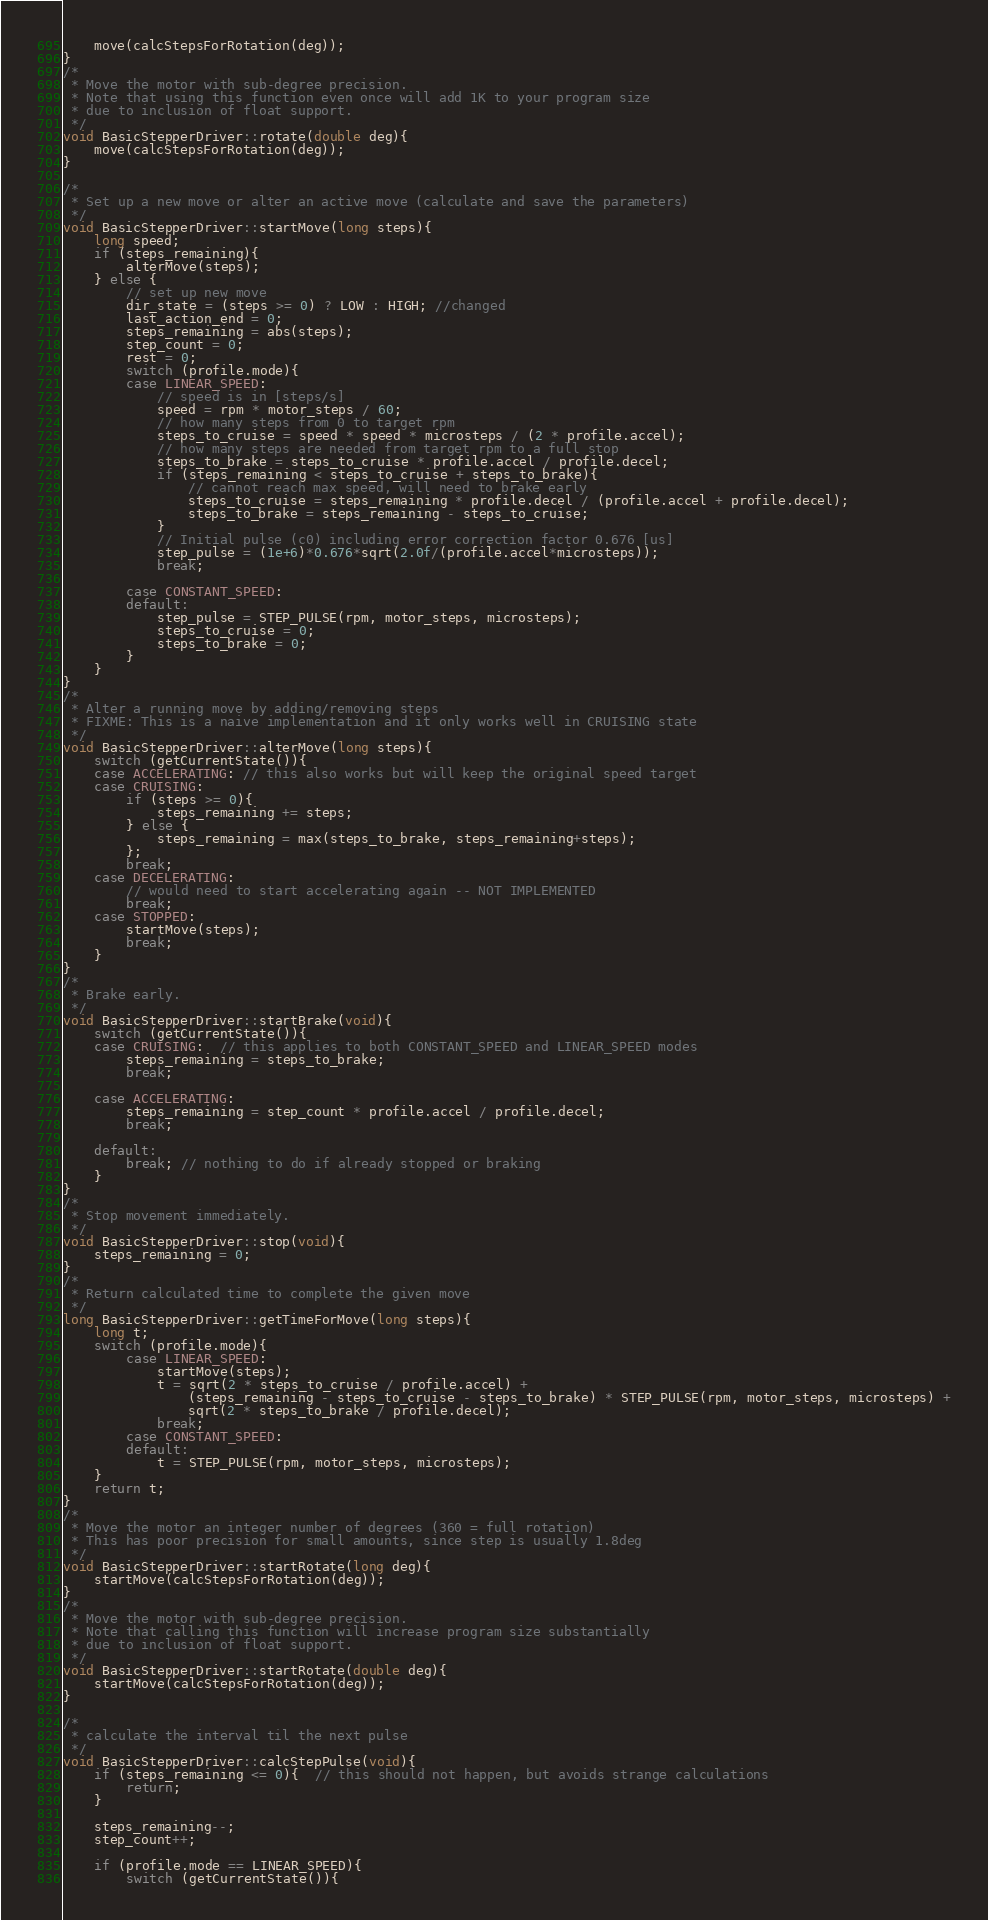Convert code to text. <code><loc_0><loc_0><loc_500><loc_500><_C++_>    move(calcStepsForRotation(deg));
}
/*
 * Move the motor with sub-degree precision.
 * Note that using this function even once will add 1K to your program size
 * due to inclusion of float support.
 */
void BasicStepperDriver::rotate(double deg){
    move(calcStepsForRotation(deg));
}

/*
 * Set up a new move or alter an active move (calculate and save the parameters)
 */
void BasicStepperDriver::startMove(long steps){
    long speed;
    if (steps_remaining){
        alterMove(steps);
    } else {
        // set up new move
        dir_state = (steps >= 0) ? LOW : HIGH; //changed
        last_action_end = 0;
        steps_remaining = abs(steps);
        step_count = 0;
        rest = 0;
        switch (profile.mode){
        case LINEAR_SPEED:
            // speed is in [steps/s]
            speed = rpm * motor_steps / 60;
            // how many steps from 0 to target rpm
            steps_to_cruise = speed * speed * microsteps / (2 * profile.accel);
            // how many steps are needed from target rpm to a full stop
            steps_to_brake = steps_to_cruise * profile.accel / profile.decel;
            if (steps_remaining < steps_to_cruise + steps_to_brake){
                // cannot reach max speed, will need to brake early
                steps_to_cruise = steps_remaining * profile.decel / (profile.accel + profile.decel);
                steps_to_brake = steps_remaining - steps_to_cruise;
            }
            // Initial pulse (c0) including error correction factor 0.676 [us]
            step_pulse = (1e+6)*0.676*sqrt(2.0f/(profile.accel*microsteps));
            break;
    
        case CONSTANT_SPEED:
        default:
            step_pulse = STEP_PULSE(rpm, motor_steps, microsteps);
            steps_to_cruise = 0;
            steps_to_brake = 0;
        }
    }
}
/*
 * Alter a running move by adding/removing steps
 * FIXME: This is a naive implementation and it only works well in CRUISING state
 */
void BasicStepperDriver::alterMove(long steps){
    switch (getCurrentState()){
    case ACCELERATING: // this also works but will keep the original speed target
    case CRUISING:
        if (steps >= 0){
            steps_remaining += steps;
        } else {
            steps_remaining = max(steps_to_brake, steps_remaining+steps);
        };
        break;
    case DECELERATING:
        // would need to start accelerating again -- NOT IMPLEMENTED
        break;
    case STOPPED:
        startMove(steps);
        break;
    }
}
/*
 * Brake early.
 */
void BasicStepperDriver::startBrake(void){
    switch (getCurrentState()){
    case CRUISING:  // this applies to both CONSTANT_SPEED and LINEAR_SPEED modes
        steps_remaining = steps_to_brake;
        break;

    case ACCELERATING:
        steps_remaining = step_count * profile.accel / profile.decel;
        break;

    default:
        break; // nothing to do if already stopped or braking
    }
}
/*
 * Stop movement immediately.
 */
void BasicStepperDriver::stop(void){
    steps_remaining = 0;
}
/*
 * Return calculated time to complete the given move
 */
long BasicStepperDriver::getTimeForMove(long steps){
    long t;
    switch (profile.mode){
        case LINEAR_SPEED:
            startMove(steps);
            t = sqrt(2 * steps_to_cruise / profile.accel) + 
                (steps_remaining - steps_to_cruise - steps_to_brake) * STEP_PULSE(rpm, motor_steps, microsteps) +
                sqrt(2 * steps_to_brake / profile.decel);
            break;
        case CONSTANT_SPEED:
        default:
            t = STEP_PULSE(rpm, motor_steps, microsteps);
    }
    return t;
}
/*
 * Move the motor an integer number of degrees (360 = full rotation)
 * This has poor precision for small amounts, since step is usually 1.8deg
 */
void BasicStepperDriver::startRotate(long deg){
    startMove(calcStepsForRotation(deg));
}
/*
 * Move the motor with sub-degree precision.
 * Note that calling this function will increase program size substantially
 * due to inclusion of float support.
 */
void BasicStepperDriver::startRotate(double deg){
    startMove(calcStepsForRotation(deg));
}

/*
 * calculate the interval til the next pulse
 */
void BasicStepperDriver::calcStepPulse(void){
    if (steps_remaining <= 0){  // this should not happen, but avoids strange calculations
        return;
    }

    steps_remaining--;
    step_count++;

    if (profile.mode == LINEAR_SPEED){
        switch (getCurrentState()){</code> 